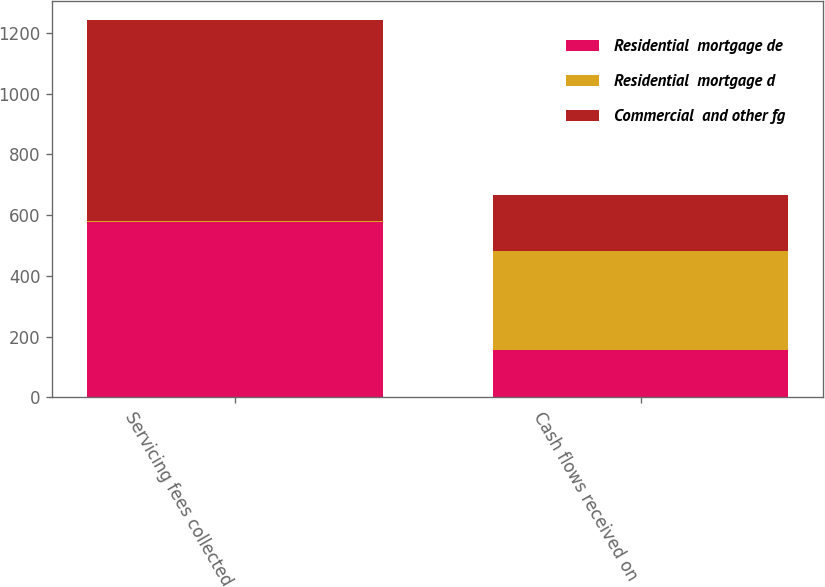Convert chart to OTSL. <chart><loc_0><loc_0><loc_500><loc_500><stacked_bar_chart><ecel><fcel>Servicing fees collected<fcel>Cash flows received on<nl><fcel>Residential  mortgage de<fcel>576<fcel>156<nl><fcel>Residential  mortgage d<fcel>5<fcel>325<nl><fcel>Commercial  and other fg<fcel>662<fcel>185<nl></chart> 